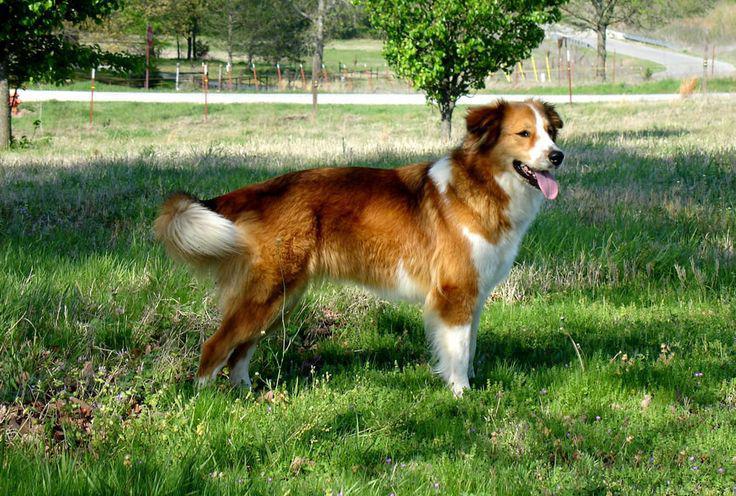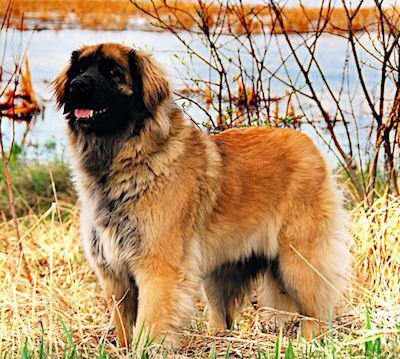The first image is the image on the left, the second image is the image on the right. Analyze the images presented: Is the assertion "One image shows a puppy and the other shows an adult dog." valid? Answer yes or no. No. 